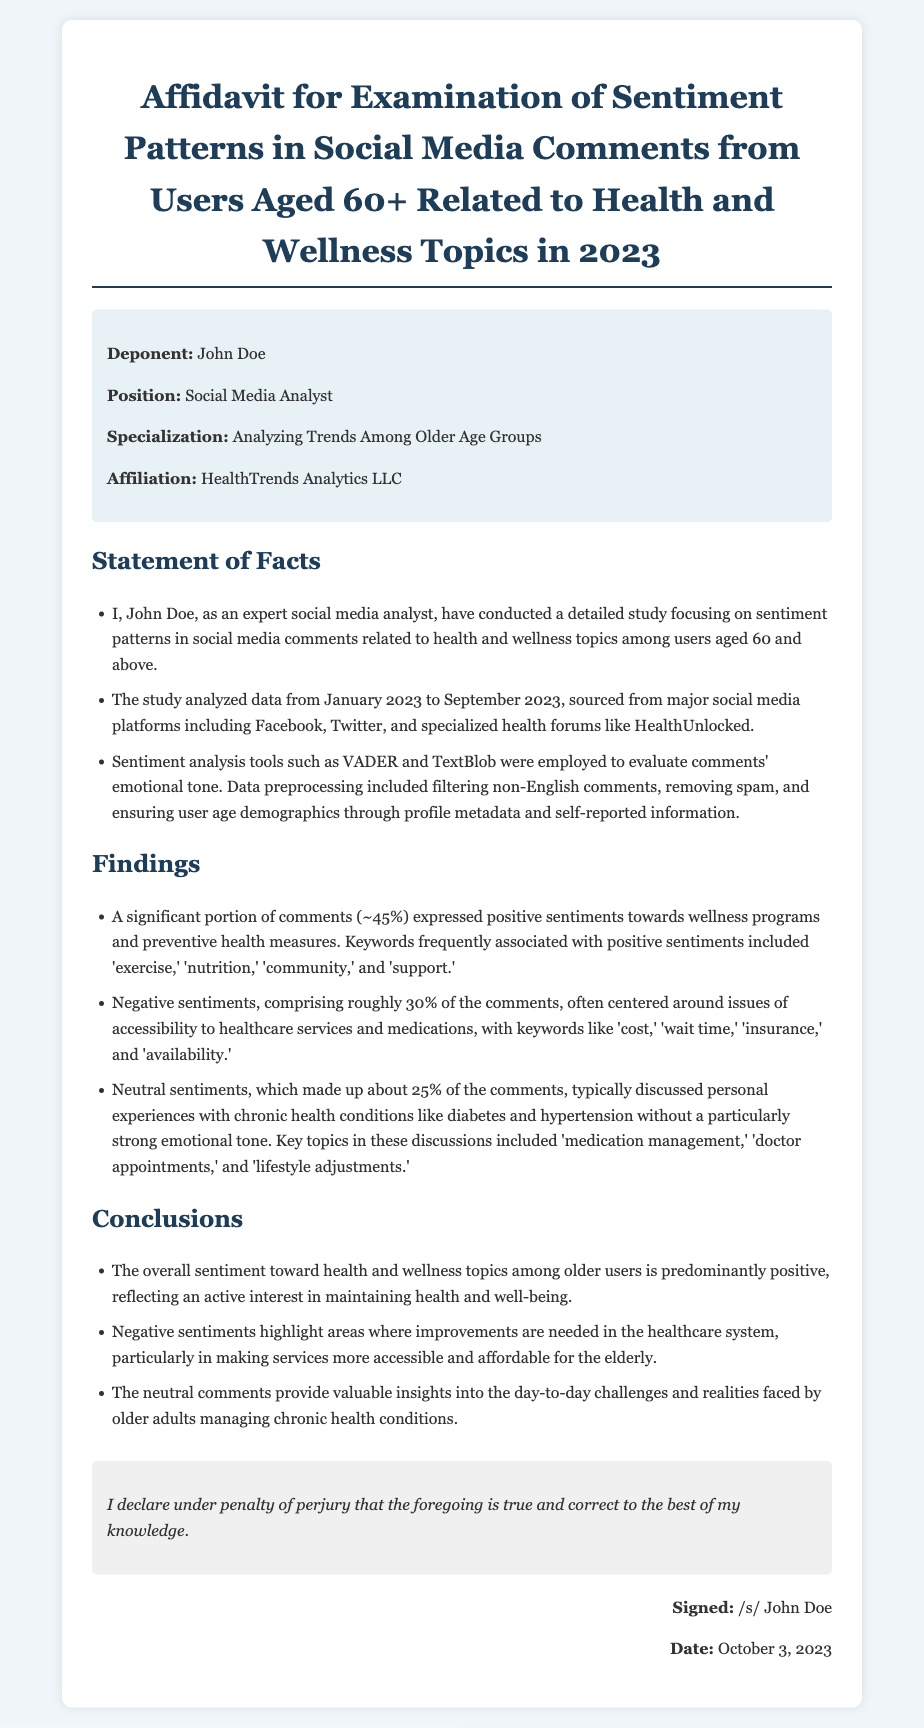what is the name of the deponent? The deponent is named John Doe as stated in the document.
Answer: John Doe what organization is the deponent affiliated with? The deponent is affiliated with HealthTrends Analytics LLC as mentioned in the affidavit.
Answer: HealthTrends Analytics LLC what percentage of comments expressed positive sentiments? The document states that approximately 45% of comments expressed positive sentiments.
Answer: 45% how many months of data were analyzed in the study? The study analyzed data from January 2023 to September 2023, which is a total of 9 months.
Answer: 9 months which sentiment analysis tools were mentioned in the document? The affidavit mentions VADER and TextBlob as the sentiment analysis tools used.
Answer: VADER and TextBlob what were the key topics discussed in neutral comments? Neutral comments typically discussed personal experiences with chronic health conditions, specifically 'medication management,' 'doctor appointments,' and 'lifestyle adjustments.'
Answer: medication management, doctor appointments, lifestyle adjustments what did negative sentiments often center around? Negative sentiments often centered around issues of accessibility to healthcare services and medications.
Answer: accessibility to healthcare services when was the affidavit signed? The affidavit was signed on October 3, 2023, as stated in the signature section.
Answer: October 3, 2023 